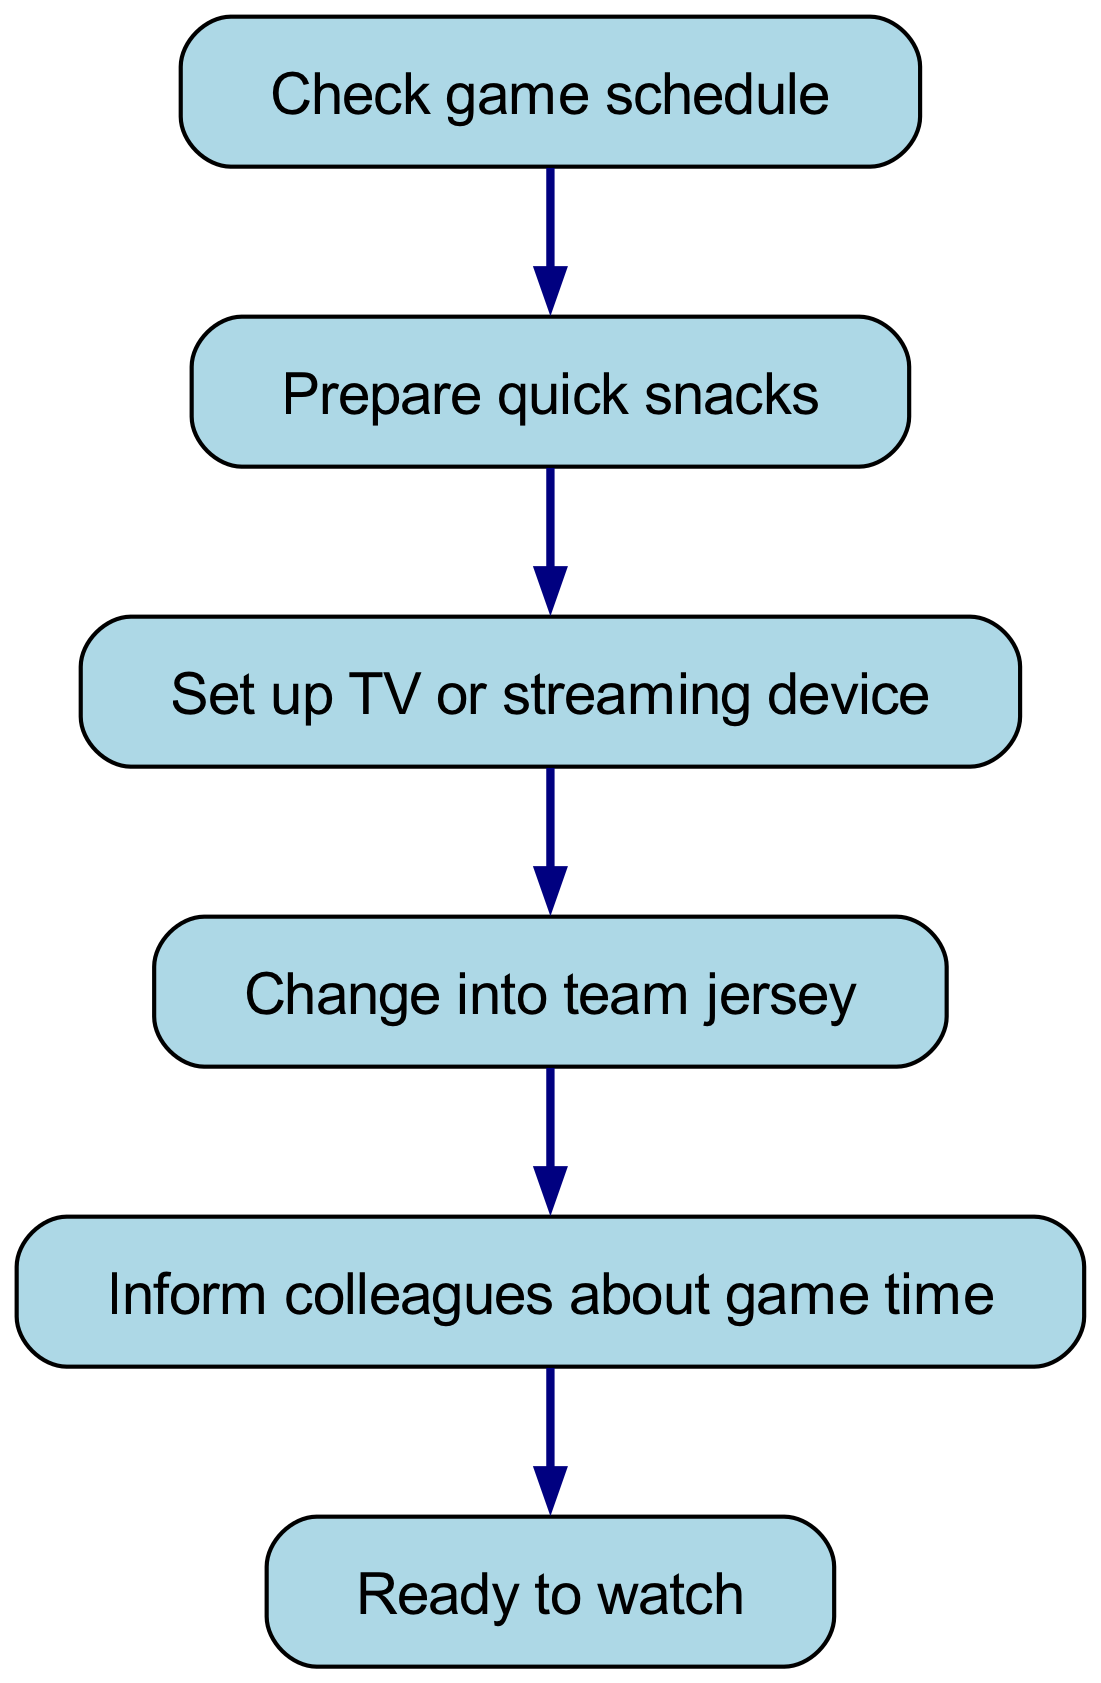What is the first step in the game day preparation routine? The first node in the diagram is "Check game schedule," which is the initial action that needs to be completed before other steps.
Answer: Check game schedule How many nodes are in the diagram? By counting all the distinct actions represented as nodes in the diagram, we find that there are 6 nodes in total.
Answer: 6 What is the final step before being ready to watch the game? The final connection in the diagram indicates that after informing colleagues about the game time, the next step is being "Ready to watch."
Answer: Ready to watch Which node directly precedes changing into a team jersey? The diagram shows that "Set up TV or streaming device" directly precedes "Change into team jersey," indicating the order of tasks.
Answer: Set up TV or streaming device What action is taken after preparing quick snacks? The edge from "Prepare quick snacks" to "Set up TV or streaming device" shows that after preparing snacks, the next action to perform is setting up the TV or streaming device.
Answer: Set up TV or streaming device What is the relationship between "Check game schedule" and "Inform colleagues about game time"? The diagram displays an indirect relationship, where you first check the game schedule, then prepare snacks, set up the TV, change jerseys, and finally inform colleagues, making it sequential.
Answer: Sequential Which node does "Change into team jersey" connect to? The diagram indicates that "Change into team jersey" connects to "Inform colleagues about game time," showing the next action after changing.
Answer: Inform colleagues about game time How many edges are present in the diagram? Counting each directed connection between nodes reveals that there are 5 edges in total within the diagram.
Answer: 5 